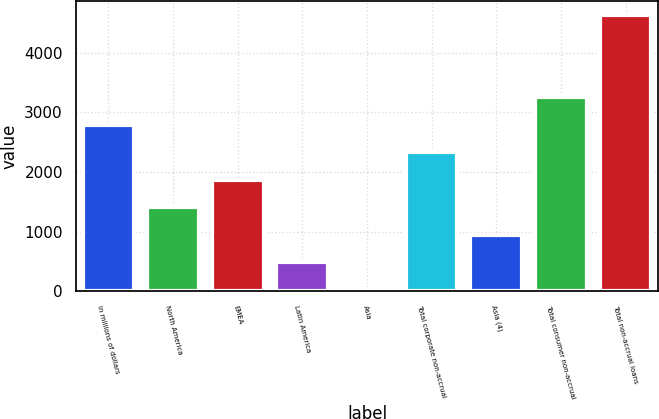<chart> <loc_0><loc_0><loc_500><loc_500><bar_chart><fcel>In millions of dollars<fcel>North America<fcel>EMEA<fcel>Latin America<fcel>Asia<fcel>Total corporate non-accrual<fcel>Asia (4)<fcel>Total consumer non-accrual<fcel>Total non-accrual loans<nl><fcel>2790.8<fcel>1409.9<fcel>1870.2<fcel>489.3<fcel>29<fcel>2330.5<fcel>949.6<fcel>3251.1<fcel>4632<nl></chart> 